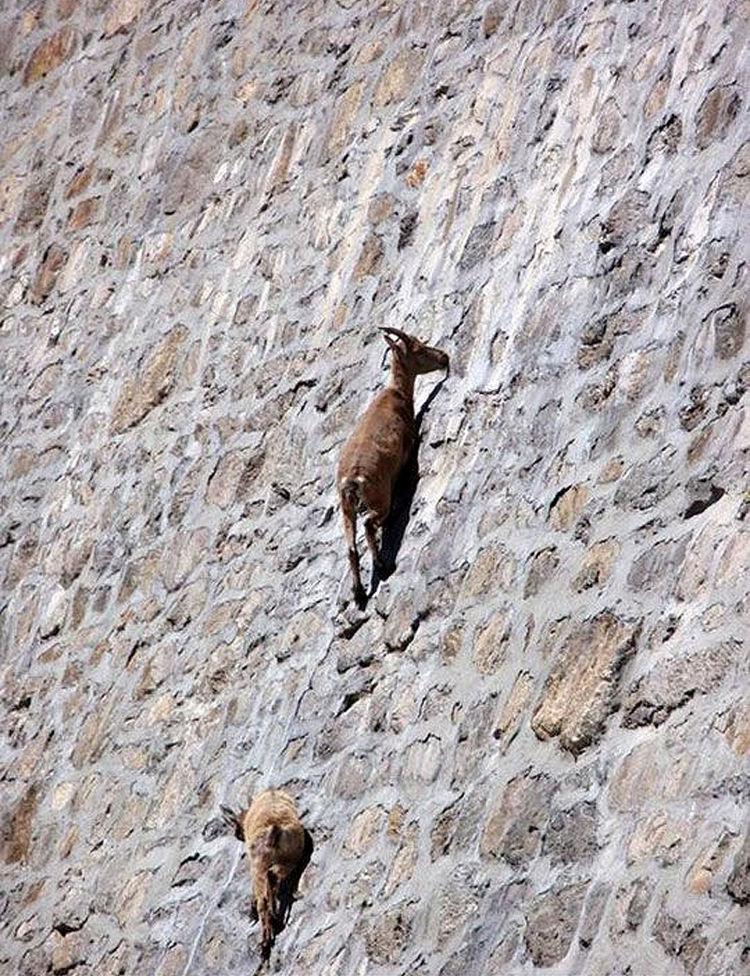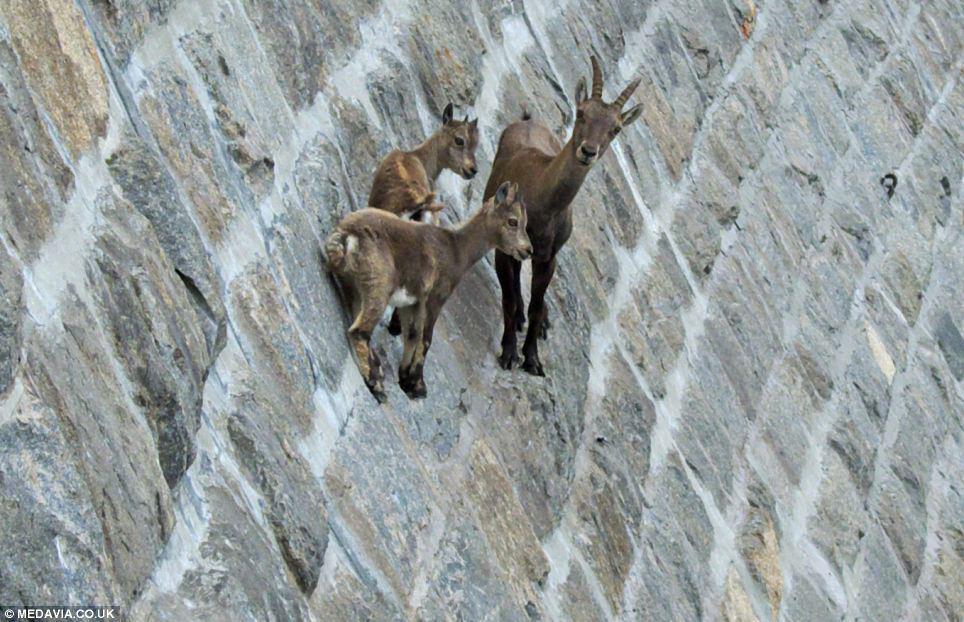The first image is the image on the left, the second image is the image on the right. Analyze the images presented: Is the assertion "The two animals in the image on the left are horned." valid? Answer yes or no. Yes. The first image is the image on the left, the second image is the image on the right. Assess this claim about the two images: "No image contains more than three hooved animals.". Correct or not? Answer yes or no. Yes. 